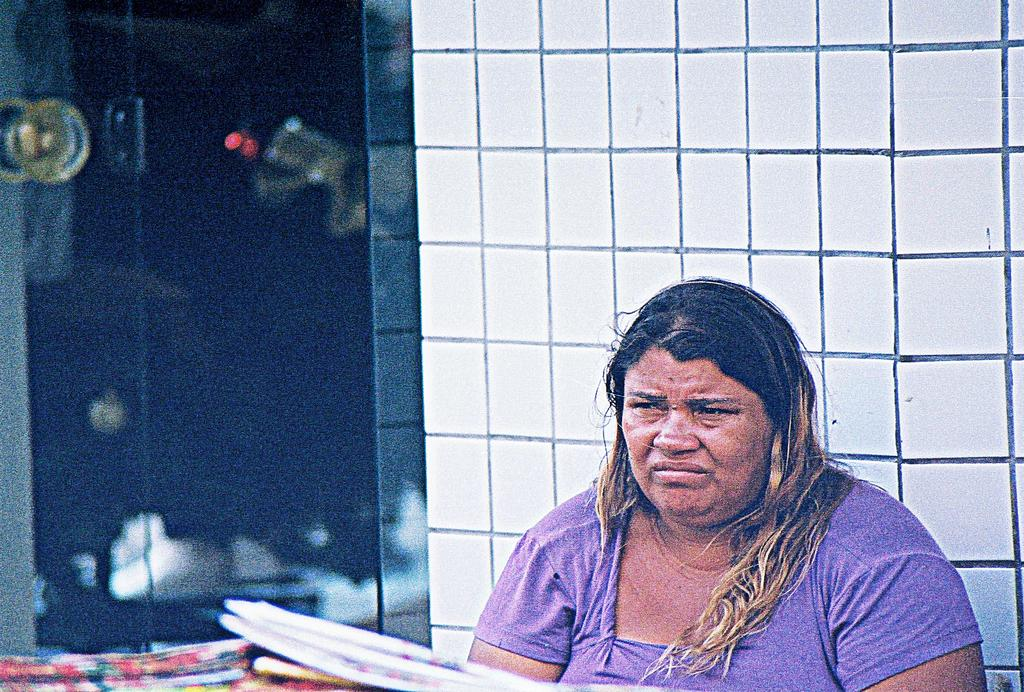Who is the main subject in the image? There is a woman in the image. What is the woman wearing? The woman is wearing a purple t-shirt. Where is the woman sitting in relation to the image? The woman is sitting in the front. In which direction is the woman looking? The woman is looking towards the left side. What type of background can be seen in the image? There are white cladding tiles visible in the background, and there is a glass door. What type of birthday celebration is happening in the image? There is no indication of a birthday celebration in the image. Can you see the coast in the background of the image? The image does not show a coast; it features white cladding tiles and a glass door in the background. 